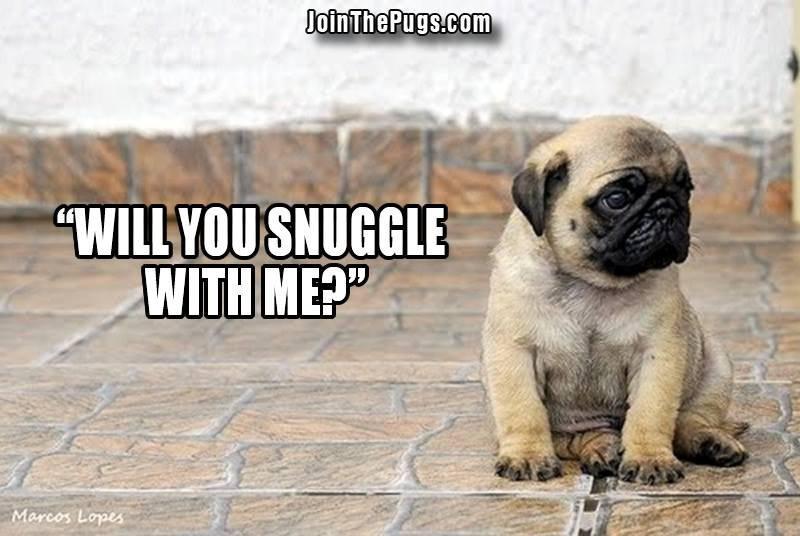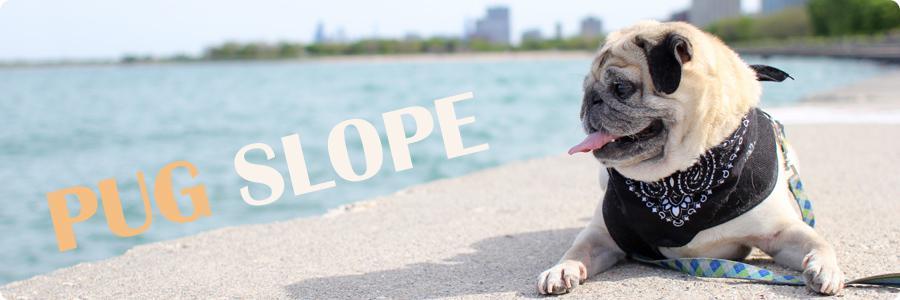The first image is the image on the left, the second image is the image on the right. Given the left and right images, does the statement "One of the dogs is lying down." hold true? Answer yes or no. Yes. The first image is the image on the left, the second image is the image on the right. Analyze the images presented: Is the assertion "One image shows a buff-beige pug with its head turned to the side and its tongue sticking out." valid? Answer yes or no. Yes. 